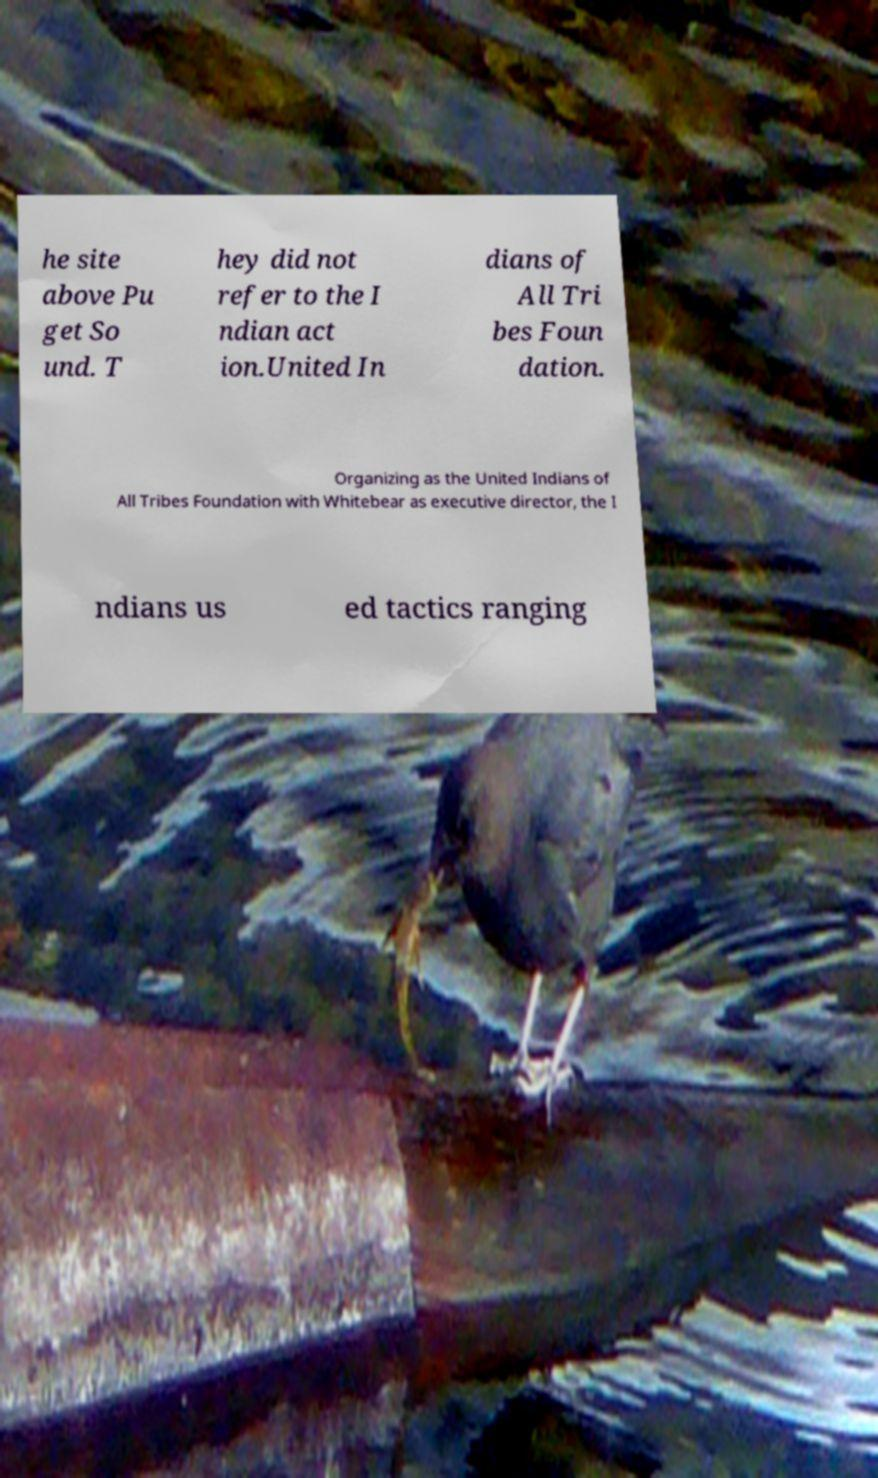I need the written content from this picture converted into text. Can you do that? he site above Pu get So und. T hey did not refer to the I ndian act ion.United In dians of All Tri bes Foun dation. Organizing as the United Indians of All Tribes Foundation with Whitebear as executive director, the I ndians us ed tactics ranging 